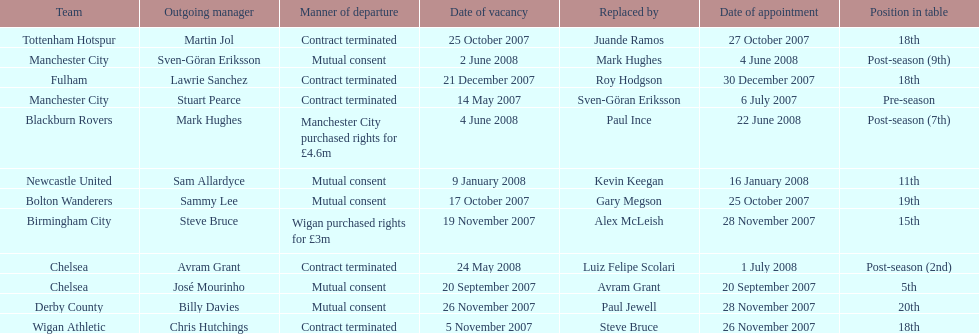What team is listed after manchester city? Chelsea. 